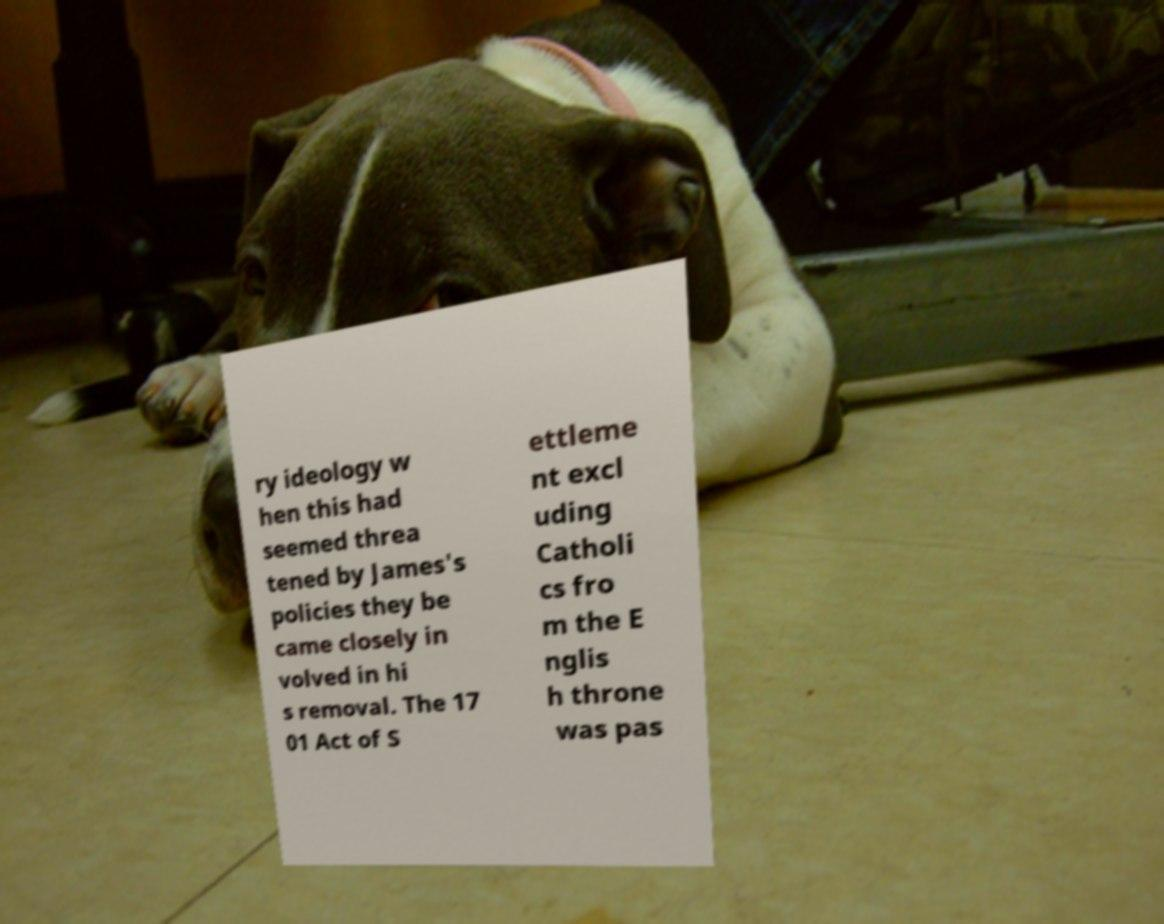There's text embedded in this image that I need extracted. Can you transcribe it verbatim? ry ideology w hen this had seemed threa tened by James's policies they be came closely in volved in hi s removal. The 17 01 Act of S ettleme nt excl uding Catholi cs fro m the E nglis h throne was pas 